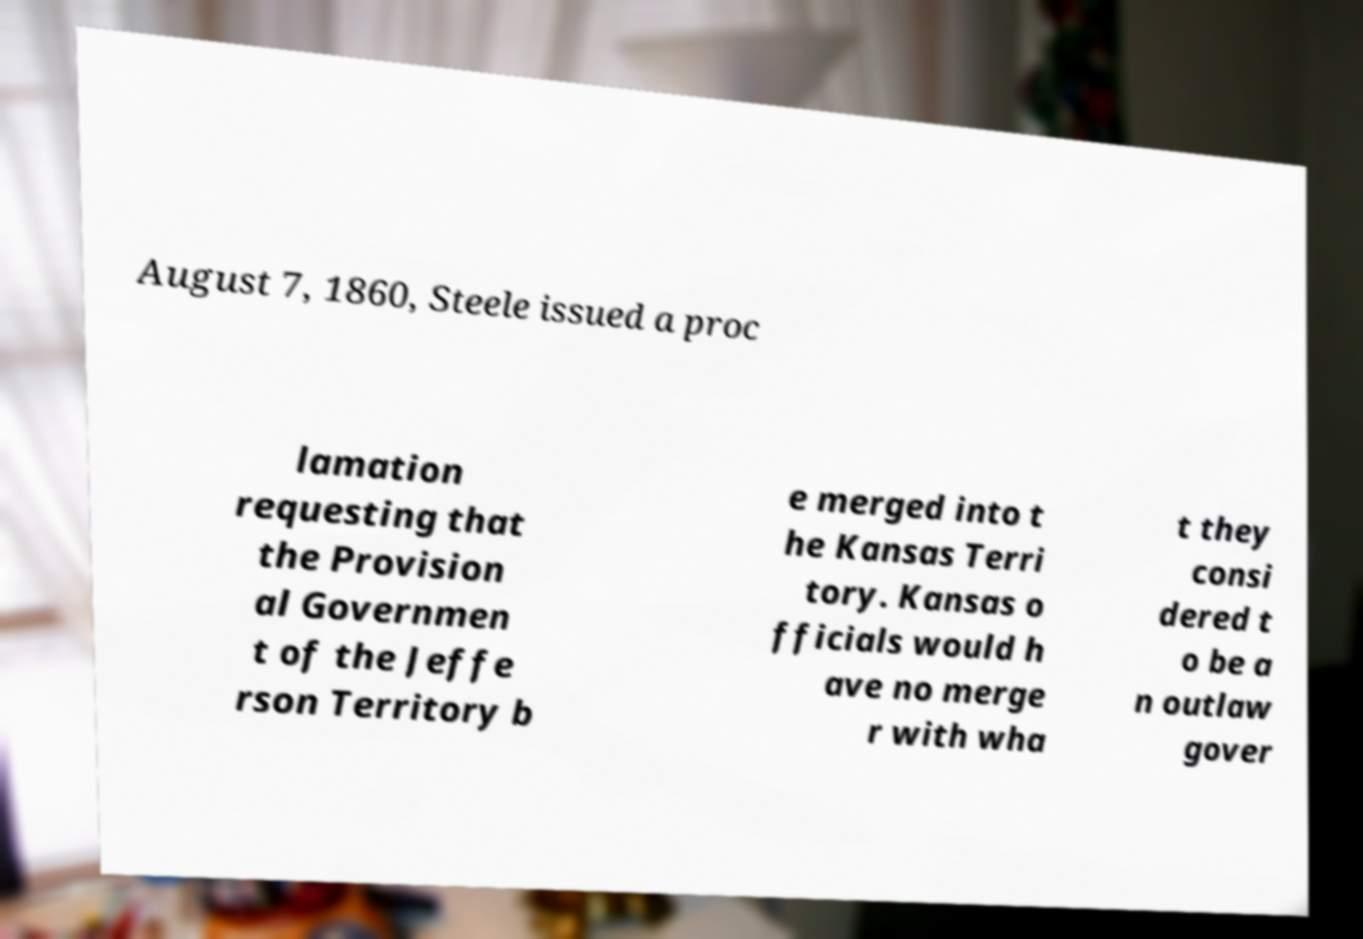What messages or text are displayed in this image? I need them in a readable, typed format. August 7, 1860, Steele issued a proc lamation requesting that the Provision al Governmen t of the Jeffe rson Territory b e merged into t he Kansas Terri tory. Kansas o fficials would h ave no merge r with wha t they consi dered t o be a n outlaw gover 